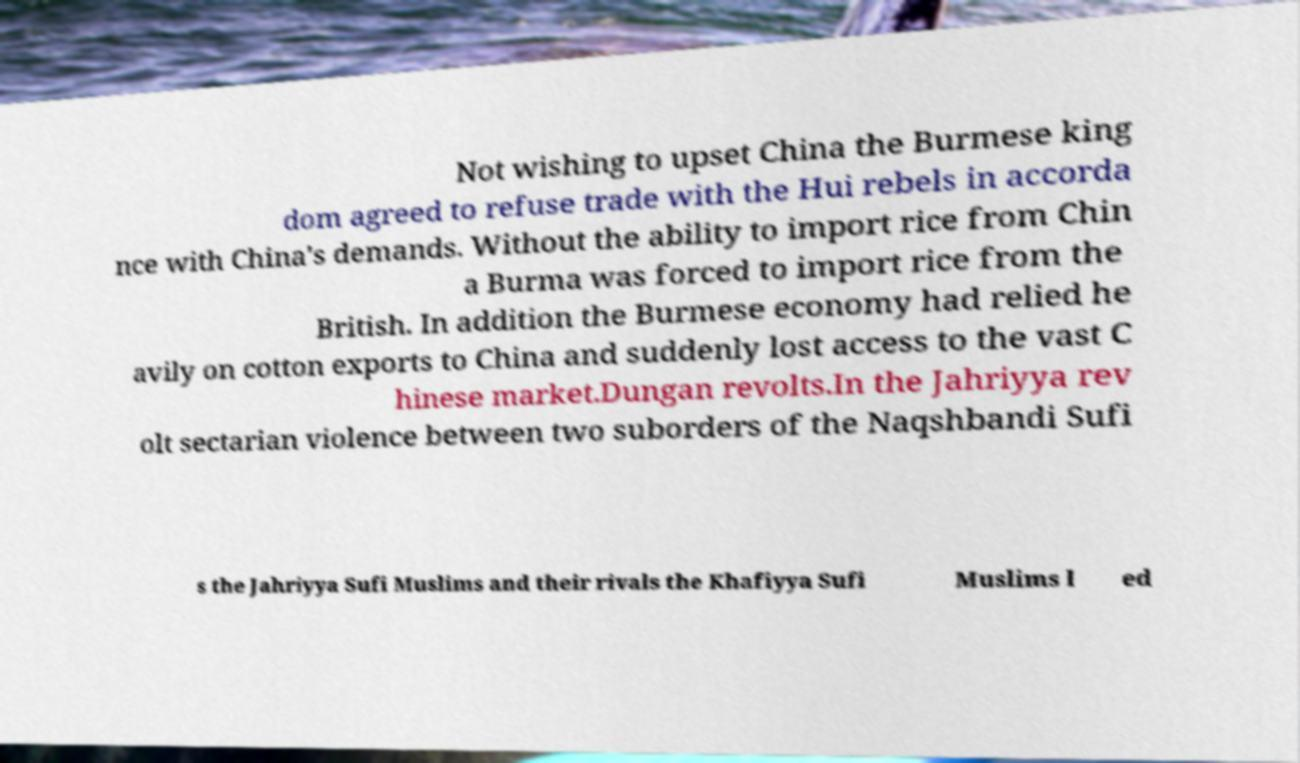I need the written content from this picture converted into text. Can you do that? Not wishing to upset China the Burmese king dom agreed to refuse trade with the Hui rebels in accorda nce with China's demands. Without the ability to import rice from Chin a Burma was forced to import rice from the British. In addition the Burmese economy had relied he avily on cotton exports to China and suddenly lost access to the vast C hinese market.Dungan revolts.In the Jahriyya rev olt sectarian violence between two suborders of the Naqshbandi Sufi s the Jahriyya Sufi Muslims and their rivals the Khafiyya Sufi Muslims l ed 